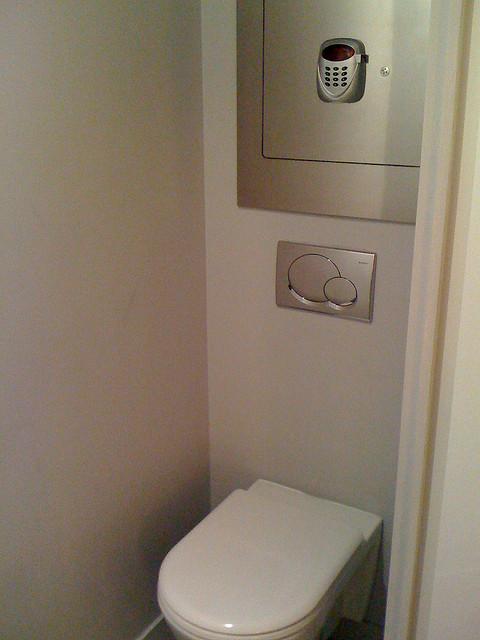Is there a trash can?
Answer briefly. No. Is the toilet seat up or down?
Be succinct. Down. Is this toilet on an airplane?
Be succinct. No. Is this a cosmetic cabinet?
Concise answer only. No. Which room is this?
Give a very brief answer. Bathroom. Is there a door beyond the toilet area?
Quick response, please. No. 